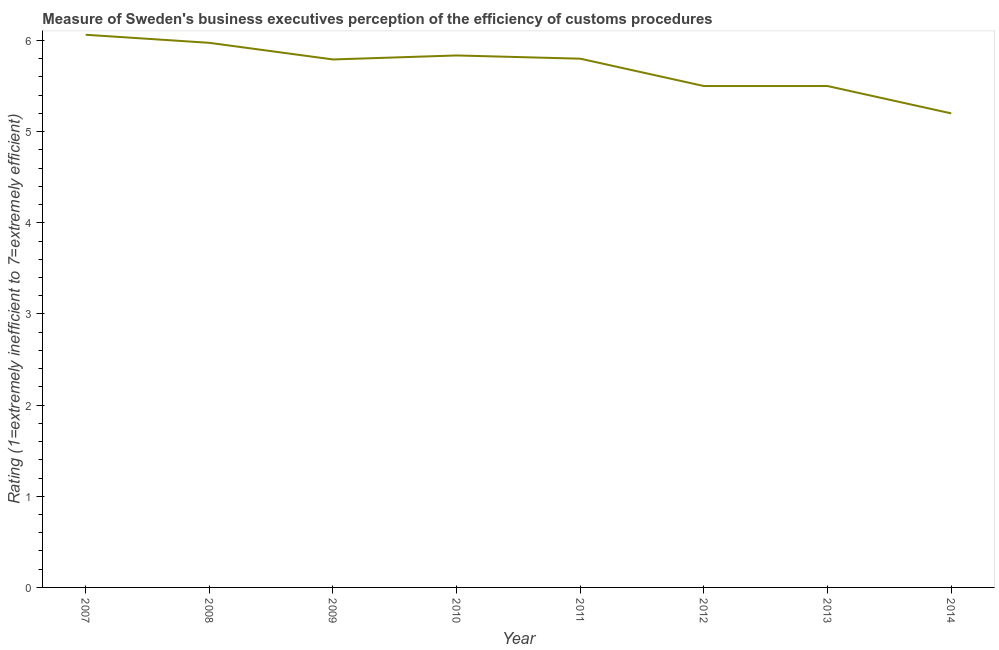What is the rating measuring burden of customs procedure in 2007?
Your answer should be compact. 6.06. Across all years, what is the maximum rating measuring burden of customs procedure?
Keep it short and to the point. 6.06. Across all years, what is the minimum rating measuring burden of customs procedure?
Offer a terse response. 5.2. What is the sum of the rating measuring burden of customs procedure?
Keep it short and to the point. 45.66. What is the difference between the rating measuring burden of customs procedure in 2009 and 2011?
Offer a terse response. -0.01. What is the average rating measuring burden of customs procedure per year?
Offer a very short reply. 5.71. What is the median rating measuring burden of customs procedure?
Your response must be concise. 5.8. What is the ratio of the rating measuring burden of customs procedure in 2012 to that in 2014?
Keep it short and to the point. 1.06. Is the difference between the rating measuring burden of customs procedure in 2007 and 2011 greater than the difference between any two years?
Keep it short and to the point. No. What is the difference between the highest and the second highest rating measuring burden of customs procedure?
Your response must be concise. 0.09. What is the difference between the highest and the lowest rating measuring burden of customs procedure?
Make the answer very short. 0.86. In how many years, is the rating measuring burden of customs procedure greater than the average rating measuring burden of customs procedure taken over all years?
Your answer should be compact. 5. How many lines are there?
Provide a succinct answer. 1. Does the graph contain grids?
Keep it short and to the point. No. What is the title of the graph?
Provide a succinct answer. Measure of Sweden's business executives perception of the efficiency of customs procedures. What is the label or title of the X-axis?
Provide a succinct answer. Year. What is the label or title of the Y-axis?
Provide a succinct answer. Rating (1=extremely inefficient to 7=extremely efficient). What is the Rating (1=extremely inefficient to 7=extremely efficient) of 2007?
Your answer should be very brief. 6.06. What is the Rating (1=extremely inefficient to 7=extremely efficient) in 2008?
Offer a very short reply. 5.97. What is the Rating (1=extremely inefficient to 7=extremely efficient) of 2009?
Make the answer very short. 5.79. What is the Rating (1=extremely inefficient to 7=extremely efficient) of 2010?
Your answer should be compact. 5.84. What is the difference between the Rating (1=extremely inefficient to 7=extremely efficient) in 2007 and 2008?
Provide a succinct answer. 0.09. What is the difference between the Rating (1=extremely inefficient to 7=extremely efficient) in 2007 and 2009?
Provide a short and direct response. 0.27. What is the difference between the Rating (1=extremely inefficient to 7=extremely efficient) in 2007 and 2010?
Offer a terse response. 0.23. What is the difference between the Rating (1=extremely inefficient to 7=extremely efficient) in 2007 and 2011?
Your response must be concise. 0.26. What is the difference between the Rating (1=extremely inefficient to 7=extremely efficient) in 2007 and 2012?
Keep it short and to the point. 0.56. What is the difference between the Rating (1=extremely inefficient to 7=extremely efficient) in 2007 and 2013?
Your answer should be very brief. 0.56. What is the difference between the Rating (1=extremely inefficient to 7=extremely efficient) in 2007 and 2014?
Provide a succinct answer. 0.86. What is the difference between the Rating (1=extremely inefficient to 7=extremely efficient) in 2008 and 2009?
Ensure brevity in your answer.  0.18. What is the difference between the Rating (1=extremely inefficient to 7=extremely efficient) in 2008 and 2010?
Give a very brief answer. 0.14. What is the difference between the Rating (1=extremely inefficient to 7=extremely efficient) in 2008 and 2011?
Provide a short and direct response. 0.17. What is the difference between the Rating (1=extremely inefficient to 7=extremely efficient) in 2008 and 2012?
Offer a very short reply. 0.47. What is the difference between the Rating (1=extremely inefficient to 7=extremely efficient) in 2008 and 2013?
Your response must be concise. 0.47. What is the difference between the Rating (1=extremely inefficient to 7=extremely efficient) in 2008 and 2014?
Provide a short and direct response. 0.77. What is the difference between the Rating (1=extremely inefficient to 7=extremely efficient) in 2009 and 2010?
Ensure brevity in your answer.  -0.04. What is the difference between the Rating (1=extremely inefficient to 7=extremely efficient) in 2009 and 2011?
Ensure brevity in your answer.  -0.01. What is the difference between the Rating (1=extremely inefficient to 7=extremely efficient) in 2009 and 2012?
Provide a succinct answer. 0.29. What is the difference between the Rating (1=extremely inefficient to 7=extremely efficient) in 2009 and 2013?
Provide a short and direct response. 0.29. What is the difference between the Rating (1=extremely inefficient to 7=extremely efficient) in 2009 and 2014?
Provide a succinct answer. 0.59. What is the difference between the Rating (1=extremely inefficient to 7=extremely efficient) in 2010 and 2011?
Offer a very short reply. 0.04. What is the difference between the Rating (1=extremely inefficient to 7=extremely efficient) in 2010 and 2012?
Ensure brevity in your answer.  0.34. What is the difference between the Rating (1=extremely inefficient to 7=extremely efficient) in 2010 and 2013?
Your response must be concise. 0.34. What is the difference between the Rating (1=extremely inefficient to 7=extremely efficient) in 2010 and 2014?
Make the answer very short. 0.64. What is the difference between the Rating (1=extremely inefficient to 7=extremely efficient) in 2011 and 2014?
Your answer should be compact. 0.6. What is the difference between the Rating (1=extremely inefficient to 7=extremely efficient) in 2012 and 2013?
Your answer should be very brief. 0. What is the difference between the Rating (1=extremely inefficient to 7=extremely efficient) in 2012 and 2014?
Offer a very short reply. 0.3. What is the difference between the Rating (1=extremely inefficient to 7=extremely efficient) in 2013 and 2014?
Your response must be concise. 0.3. What is the ratio of the Rating (1=extremely inefficient to 7=extremely efficient) in 2007 to that in 2008?
Provide a succinct answer. 1.01. What is the ratio of the Rating (1=extremely inefficient to 7=extremely efficient) in 2007 to that in 2009?
Give a very brief answer. 1.05. What is the ratio of the Rating (1=extremely inefficient to 7=extremely efficient) in 2007 to that in 2010?
Make the answer very short. 1.04. What is the ratio of the Rating (1=extremely inefficient to 7=extremely efficient) in 2007 to that in 2011?
Your answer should be very brief. 1.04. What is the ratio of the Rating (1=extremely inefficient to 7=extremely efficient) in 2007 to that in 2012?
Provide a short and direct response. 1.1. What is the ratio of the Rating (1=extremely inefficient to 7=extremely efficient) in 2007 to that in 2013?
Provide a succinct answer. 1.1. What is the ratio of the Rating (1=extremely inefficient to 7=extremely efficient) in 2007 to that in 2014?
Ensure brevity in your answer.  1.17. What is the ratio of the Rating (1=extremely inefficient to 7=extremely efficient) in 2008 to that in 2009?
Provide a short and direct response. 1.03. What is the ratio of the Rating (1=extremely inefficient to 7=extremely efficient) in 2008 to that in 2012?
Your answer should be very brief. 1.09. What is the ratio of the Rating (1=extremely inefficient to 7=extremely efficient) in 2008 to that in 2013?
Offer a terse response. 1.09. What is the ratio of the Rating (1=extremely inefficient to 7=extremely efficient) in 2008 to that in 2014?
Your answer should be compact. 1.15. What is the ratio of the Rating (1=extremely inefficient to 7=extremely efficient) in 2009 to that in 2010?
Your answer should be compact. 0.99. What is the ratio of the Rating (1=extremely inefficient to 7=extremely efficient) in 2009 to that in 2011?
Provide a short and direct response. 1. What is the ratio of the Rating (1=extremely inefficient to 7=extremely efficient) in 2009 to that in 2012?
Provide a short and direct response. 1.05. What is the ratio of the Rating (1=extremely inefficient to 7=extremely efficient) in 2009 to that in 2013?
Keep it short and to the point. 1.05. What is the ratio of the Rating (1=extremely inefficient to 7=extremely efficient) in 2009 to that in 2014?
Give a very brief answer. 1.11. What is the ratio of the Rating (1=extremely inefficient to 7=extremely efficient) in 2010 to that in 2012?
Offer a very short reply. 1.06. What is the ratio of the Rating (1=extremely inefficient to 7=extremely efficient) in 2010 to that in 2013?
Your answer should be compact. 1.06. What is the ratio of the Rating (1=extremely inefficient to 7=extremely efficient) in 2010 to that in 2014?
Your response must be concise. 1.12. What is the ratio of the Rating (1=extremely inefficient to 7=extremely efficient) in 2011 to that in 2012?
Offer a very short reply. 1.05. What is the ratio of the Rating (1=extremely inefficient to 7=extremely efficient) in 2011 to that in 2013?
Your response must be concise. 1.05. What is the ratio of the Rating (1=extremely inefficient to 7=extremely efficient) in 2011 to that in 2014?
Provide a short and direct response. 1.11. What is the ratio of the Rating (1=extremely inefficient to 7=extremely efficient) in 2012 to that in 2014?
Keep it short and to the point. 1.06. What is the ratio of the Rating (1=extremely inefficient to 7=extremely efficient) in 2013 to that in 2014?
Ensure brevity in your answer.  1.06. 